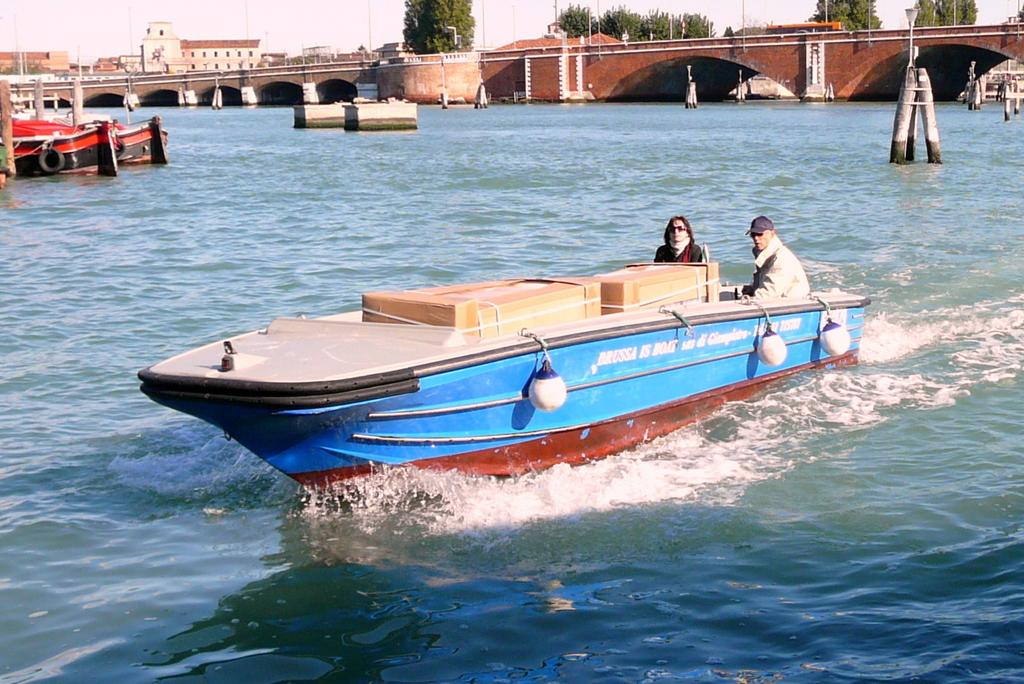What type of vehicle are the people using in the image? The people are on a motor boat in the image. Where is the motor boat sailing? The motor boat is sailing in the river. What is the motor boat passing under in the image? The motor boat is under a tunnel bridge. What can be seen in the background of the image? There are many boats, poles, buildings, and trees visible in the background of the image. How does the motor boat aid in the digestion process of the people on board? The motor boat does not aid in the digestion process of the people on board; it is a mode of transportation. What type of wire can be seen connecting the buildings in the image? There is no wire connecting the buildings visible in the image. 